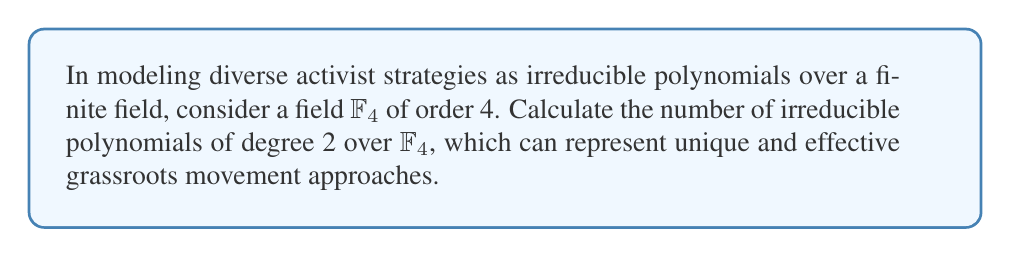Show me your answer to this math problem. To solve this problem, we'll follow these steps:

1) First, recall that $\mathbb{F}_4$ is a field with 4 elements, typically represented as $\{0, 1, \alpha, \alpha+1\}$, where $\alpha$ is a root of $x^2 + x + 1$.

2) The total number of polynomials of degree 2 over $\mathbb{F}_4$ is $4^2 = 16$, as we have 4 choices for each coefficient.

3) To find the number of irreducible polynomials, we need to subtract the number of reducible polynomials from the total.

4) Reducible polynomials of degree 2 are those that can be factored as $(x-a)(x-b)$, where $a,b \in \mathbb{F}_4$.

5) We can count these reducible polynomials:
   - $(x-0)(x-0)$, $(x-1)(x-1)$, $(x-\alpha)(x-\alpha)$, $(x-(\alpha+1))(x-(\alpha+1))$: 4 polynomials
   - $(x-0)(x-1)$, $(x-0)(x-\alpha)$, $(x-0)(x-(\alpha+1))$, $(x-1)(x-\alpha)$, $(x-1)(x-(\alpha+1))$, $(x-\alpha)(x-(\alpha+1))$: 6 polynomials

6) In total, there are 10 reducible polynomials of degree 2 over $\mathbb{F}_4$.

7) Therefore, the number of irreducible polynomials is $16 - 10 = 6$.

This result shows that in our model, there are 6 unique and effective activist strategies that cannot be broken down into simpler approaches.
Answer: 6 